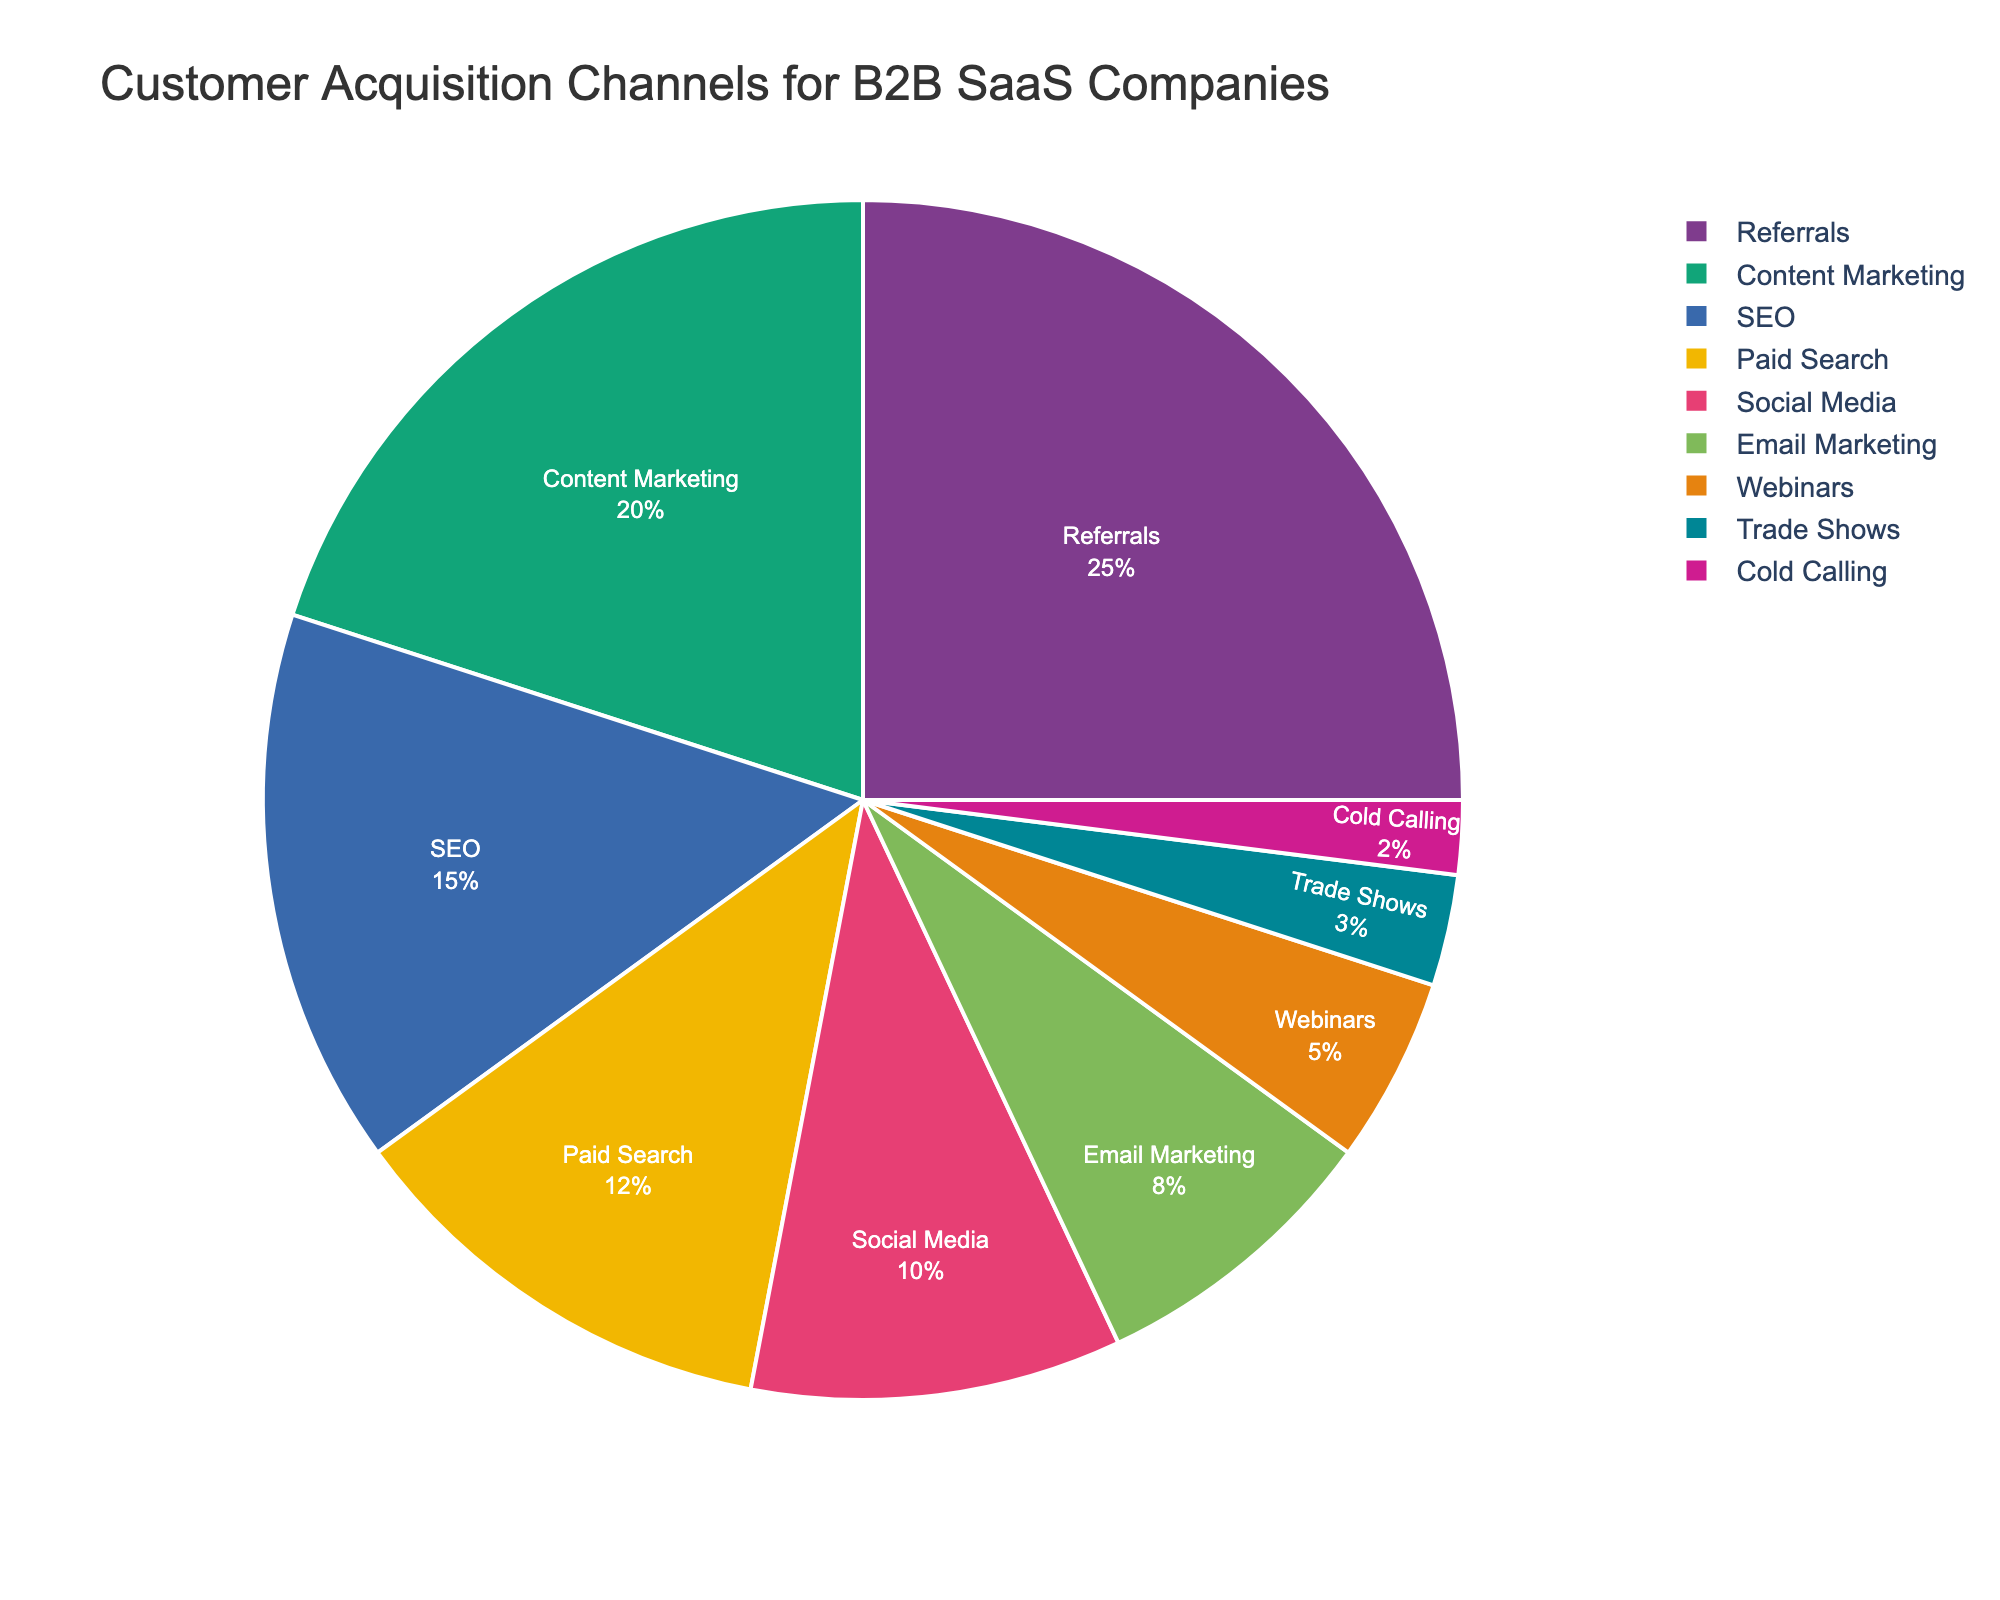What's the largest customer acquisition channel? The largest section can be identified visually by looking for the biggest slice of the pie chart. The biggest slice belongs to "Referrals" at 25%.
Answer: Referrals What’s the total percentage for customer acquisition channels related to direct interaction, including 'Webinars,' 'Trade Shows,' and 'Cold Calling'? To find this, add the percentages of 'Webinars' (5%), 'Trade Shows' (3%), and 'Cold Calling' (2%). The total is 5 + 3 + 2 = 10%.
Answer: 10% Which channel has a smaller share, 'Paid Search' or 'Social Media'? Visually compare the sizes of the pie chart slices for 'Paid Search' and 'Social Media'. 'Paid Search' is 12% and 'Social Media' is 10%; thus, 'Social Media' has a smaller share.
Answer: Social Media By how much does 'Content Marketing' exceed 'Email Marketing' in percentage? Subtract the percentage of 'Email Marketing' (8%) from 'Content Marketing' (20%). The result is 20 - 8 = 12%.
Answer: 12% What is the combined percentage of 'Referrals' and 'SEO'? Add the percentages for 'Referrals' (25%) and 'SEO' (15%). The total is 25 + 15 = 40%.
Answer: 40% How does the size of the 'Trade Shows' segment compare to the combined size of 'Webinars' and 'Cold Calling'? First, find the combined size of 'Webinars' (5%) and 'Cold Calling' (2%), which is 5 + 2 = 7%. Then, visually compare it to 'Trade Shows' (3%). 'Trade Shows' is smaller.
Answer: Smaller Which channels have a percentage lower than 'Content Marketing'? Look at the pie chart sections and compare each one to 'Content Marketing' (20%). Channels lower than 20% are: 'SEO' (15%), 'Paid Search' (12%), 'Social Media' (10%), 'Email Marketing' (8%), 'Webinars' (5%), 'Trade Shows' (3%), and 'Cold Calling' (2%).
Answer: SEO, Paid Search, Social Media, Email Marketing, Webinars, Trade Shows, Cold Calling What's the second largest customer acquisition channel? Identify the second largest section of the pie chart after finding the largest ('Referrals'). The next largest section is 'Content Marketing' at 20%.
Answer: Content Marketing Which channel has the least percentage? Look for the smallest slice in the pie chart. The smallest segment is 'Cold Calling' at 2%.
Answer: Cold Calling 